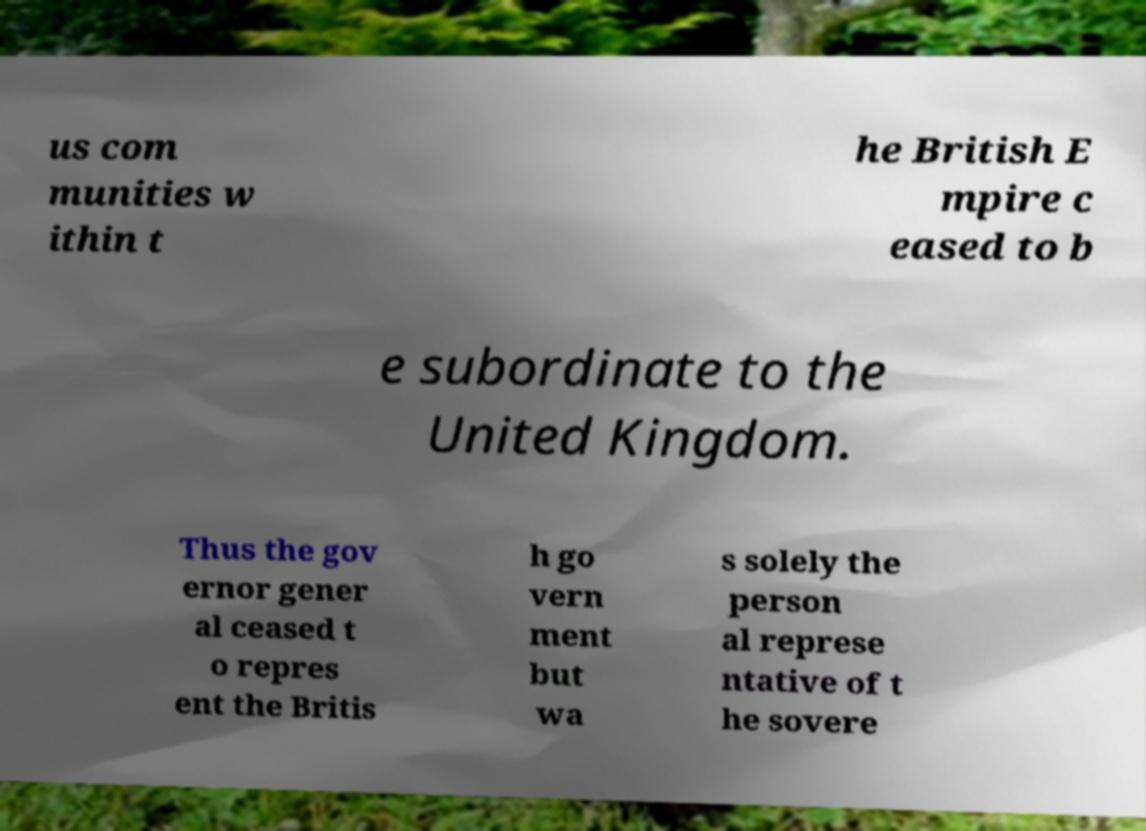Can you accurately transcribe the text from the provided image for me? us com munities w ithin t he British E mpire c eased to b e subordinate to the United Kingdom. Thus the gov ernor gener al ceased t o repres ent the Britis h go vern ment but wa s solely the person al represe ntative of t he sovere 